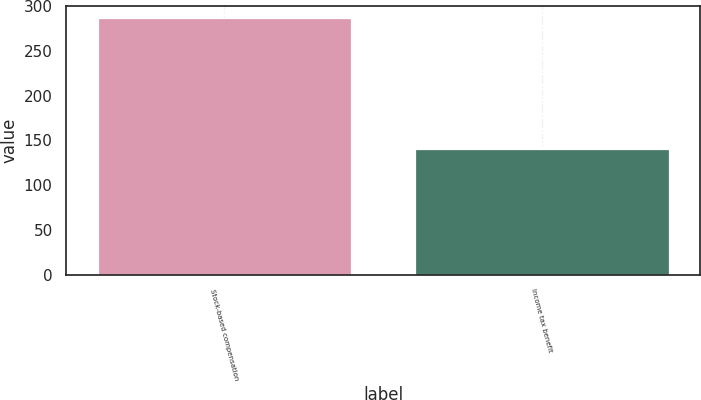<chart> <loc_0><loc_0><loc_500><loc_500><bar_chart><fcel>Stock-based compensation<fcel>Income tax benefit<nl><fcel>286<fcel>141<nl></chart> 